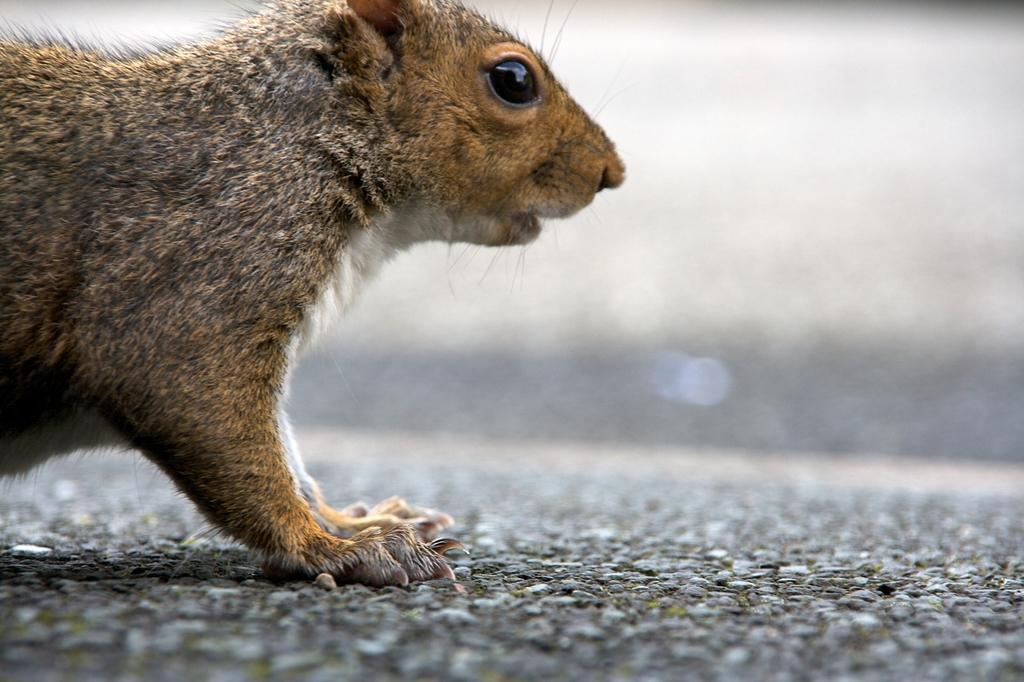What type of creature can be seen in the image? There is an animal in the image. Where is the animal located in the image? The animal is on the ground. Can you describe the background of the image? The background of the image is blurry. What is the chance of the animal walking on the edge of the sky in the image? There is no sky present in the image, and the animal is on the ground, so it cannot walk on the edge of the sky. 